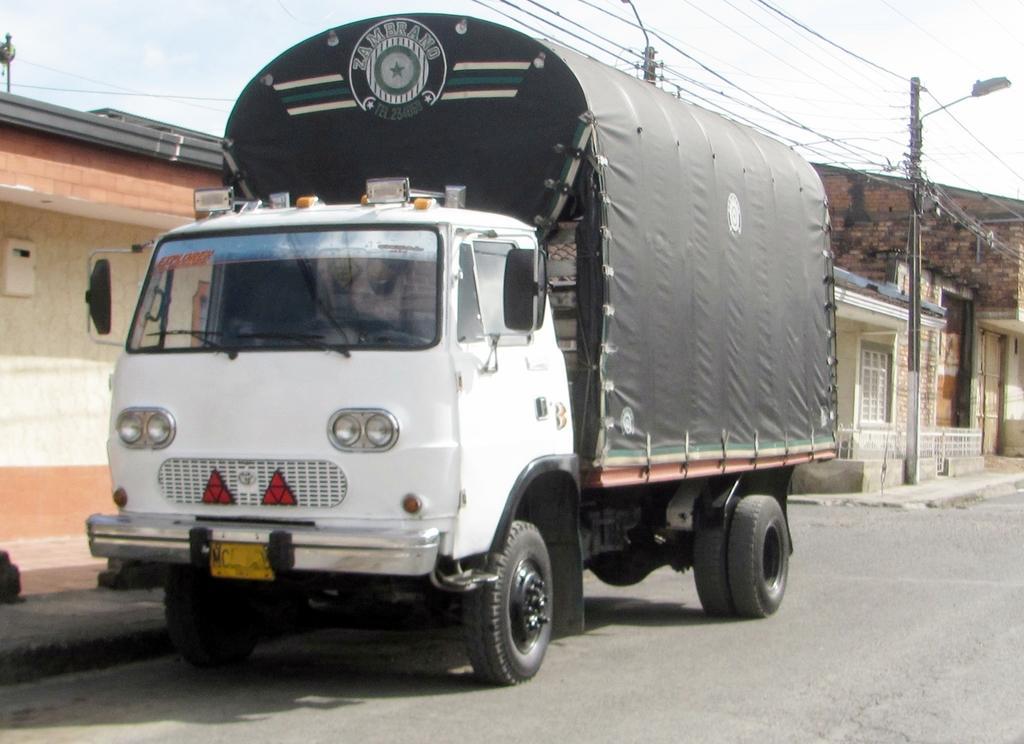Please provide a concise description of this image. In the picture I can see a lorry on the road. I can see two electric poles on the side of the road. There are houses on the right side. There are clouds in the sky. 